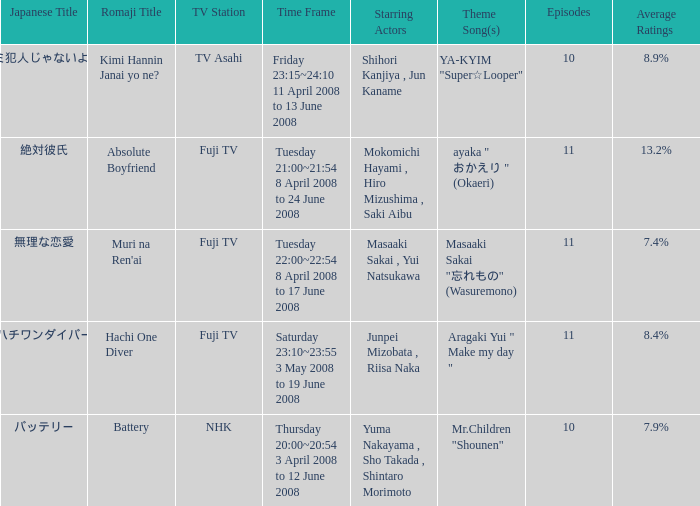How many titles held an average rating of 1.0. 